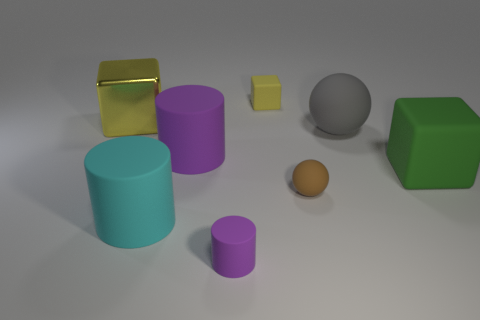What is the color of the sphere that is the same size as the yellow matte block?
Give a very brief answer. Brown. Does the large cyan cylinder have the same material as the big yellow object?
Give a very brief answer. No. What material is the yellow cube on the right side of the tiny thing that is in front of the tiny brown thing?
Offer a terse response. Rubber. Are there more large things that are in front of the small brown matte sphere than tiny red metal spheres?
Make the answer very short. Yes. What number of other things are there of the same size as the cyan cylinder?
Offer a terse response. 4. Do the metallic block and the tiny matte block have the same color?
Give a very brief answer. Yes. There is a tiny matte thing to the right of the yellow object right of the large thing in front of the green matte thing; what is its color?
Offer a terse response. Brown. How many tiny rubber things are in front of the big cube that is in front of the yellow object that is in front of the small yellow cube?
Your answer should be very brief. 2. Are there any other things that have the same color as the small ball?
Make the answer very short. No. There is a yellow object that is on the right side of the yellow shiny block; is its size the same as the big cyan object?
Your response must be concise. No. 